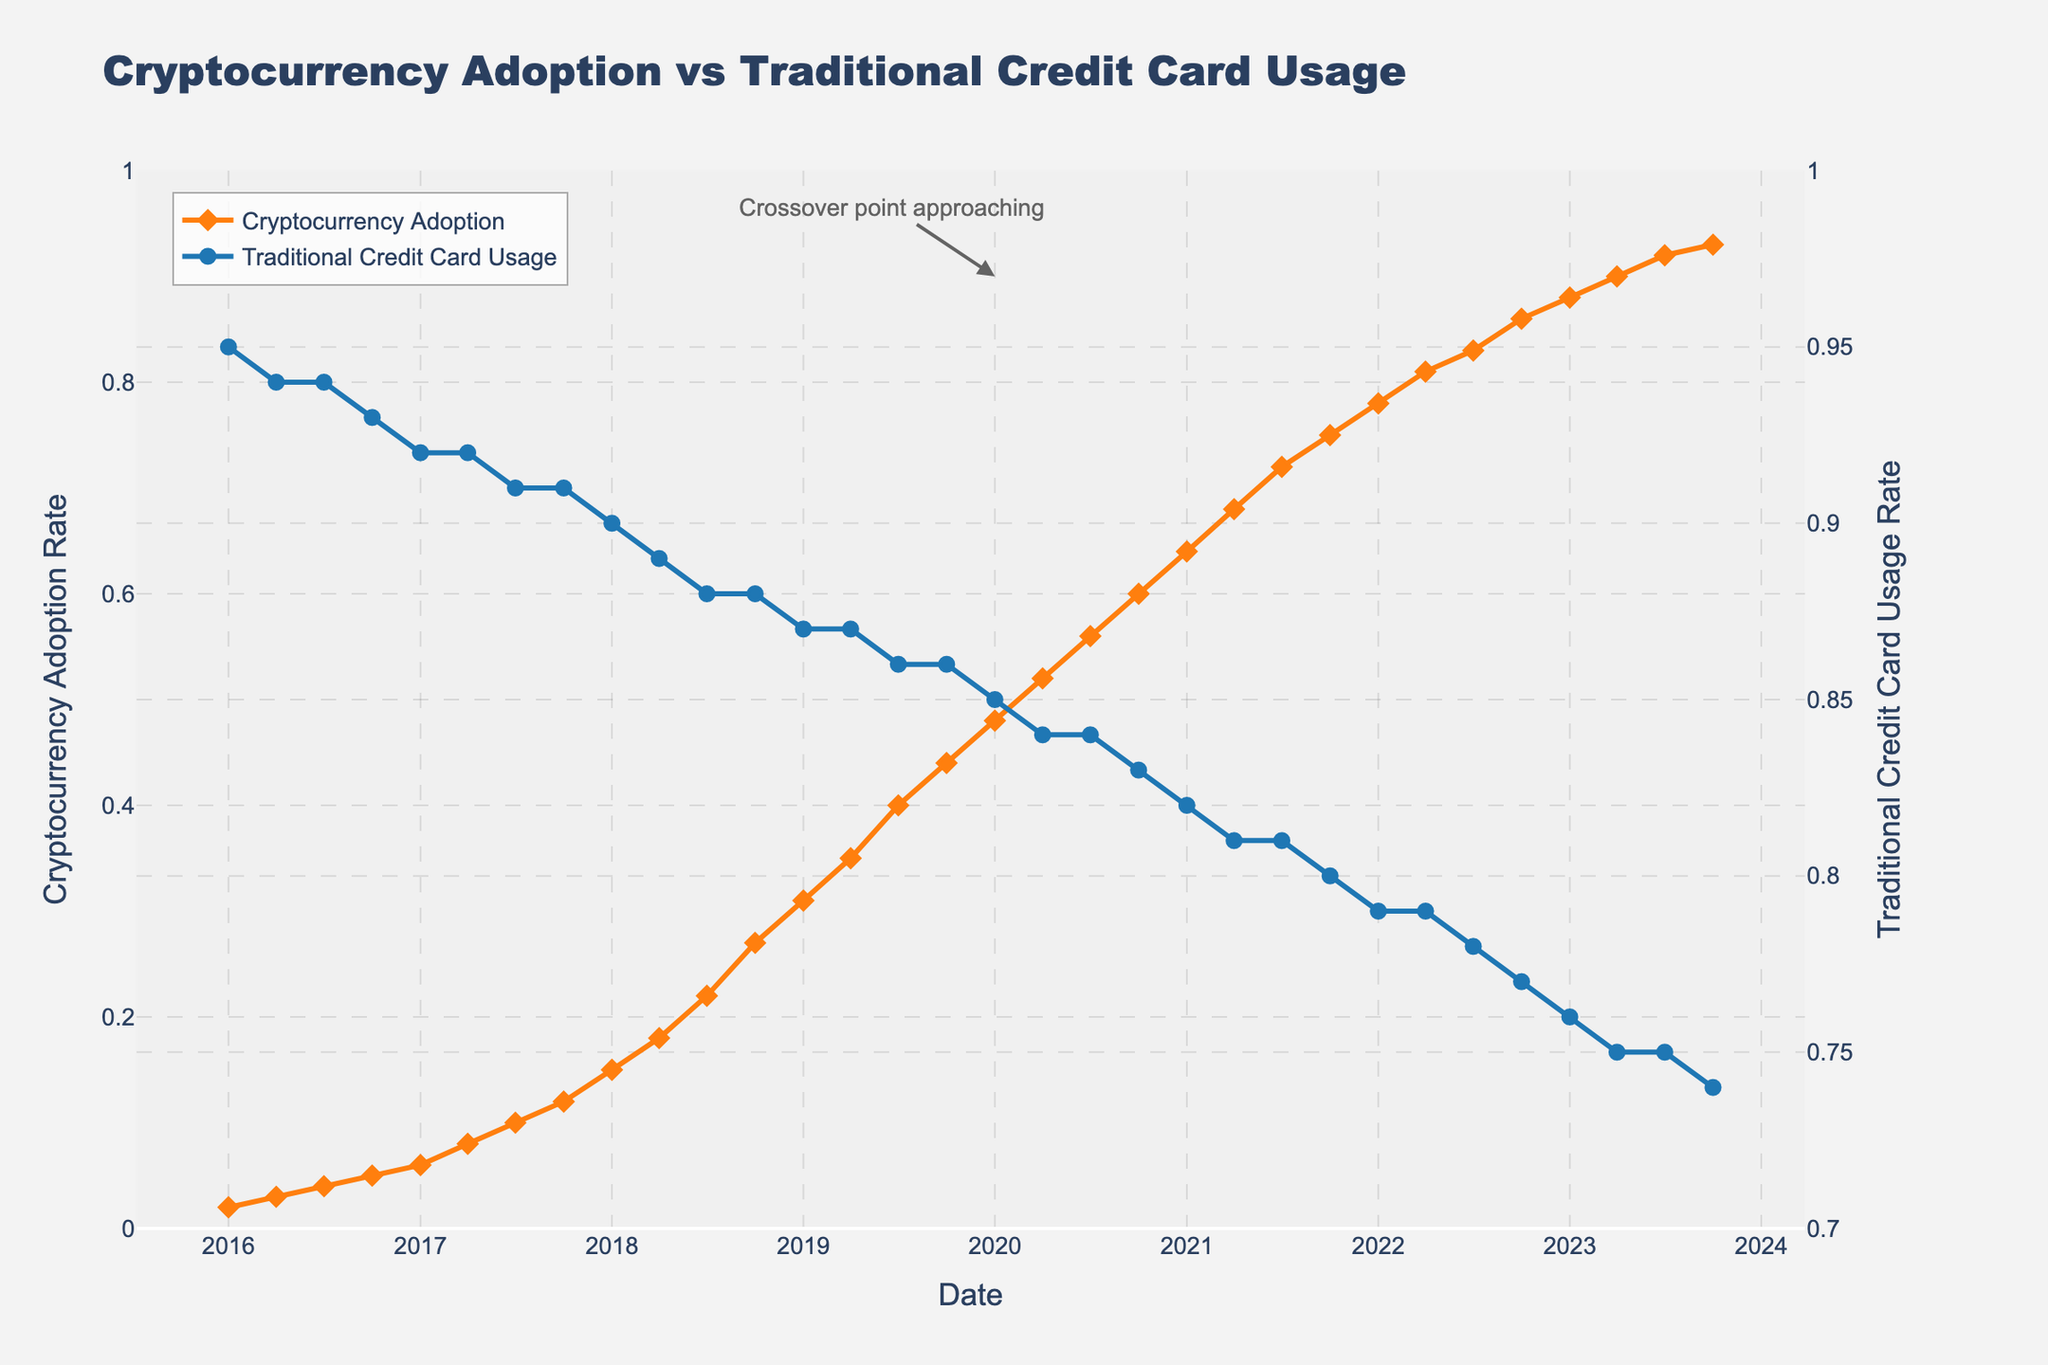What is the title of the plot? The title is indicated at the top center of the plot.
Answer: Cryptocurrency Adoption vs Traditional Credit Card Usage What are the lines and markers used to represent cryptocurrency adoption? The cryptocurrency adoption is represented by a line plot with diamond-shaped markers, both in orange color.
Answer: Orange line with diamond markers What date does the chart begin with? The x-axis starts with the date 2016-01, which can be inferred from the earliest data point.
Answer: January 2016 What is the consumption rate of cryptocurrency adoption in January 2018? Look for the data point on the orange line corresponding to January 2018 and read the adoption rate from the y-axis on the left.
Answer: 0.15 Between 2018 and 2020, did cryptocurrency adoption exceed traditional credit card usage at any point? Compare both lines in that period. The blue line (credit card usage) remains above the orange line (cryptocurrency adoption), so it did not exceed.
Answer: No What is the rate of traditional credit card usage in April 2022? Locate the data point on the blue line corresponding to April 2022 and refer to the right y-axis for the value.
Answer: 0.79 By how much has cryptocurrency adoption increased from January 2016 to October 2023? Subtract the adoption rate in January 2016 (0.02) from the rate in October 2023 (0.93).
Answer: 0.91 In which year did cryptocurrency adoption surpass 50%? Identify the point where the orange line crosses the 0.5 mark on the left y-axis and note the corresponding year.
Answer: 2020 What is the annotation mentioned in the plot? The annotation near January 2020 indicates a significant event approaching.
Answer: Crossover point approaching Compare traditional credit card usage rates in April 2017 and April 2021. Which is higher? Find the values of the usage in both months (April 2017: 0.92, April 2021: 0.81). The April 2017 value is higher.
Answer: April 2017 